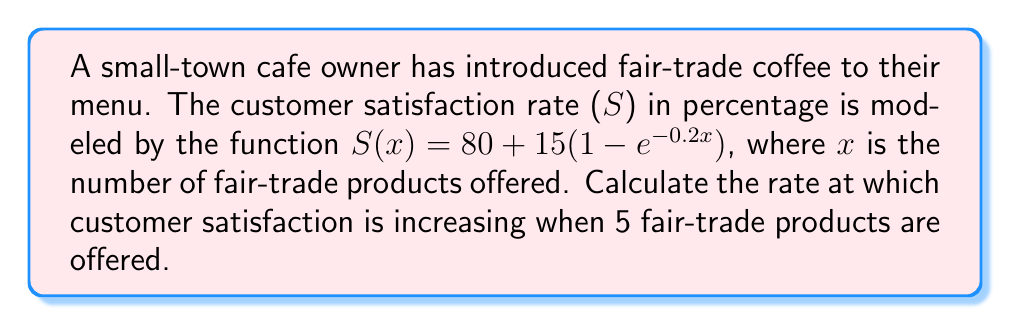Teach me how to tackle this problem. To find the rate at which customer satisfaction is increasing, we need to calculate the derivative of the function $S(x)$ and evaluate it at $x = 5$.

Step 1: Find the derivative of $S(x)$
$$\frac{d}{dx}S(x) = \frac{d}{dx}[80 + 15(1 - e^{-0.2x})]$$
$$S'(x) = 0 + 15 \cdot \frac{d}{dx}(1 - e^{-0.2x})$$
$$S'(x) = 15 \cdot (-1) \cdot (-0.2e^{-0.2x})$$
$$S'(x) = 3e^{-0.2x}$$

Step 2: Evaluate $S'(x)$ at $x = 5$
$$S'(5) = 3e^{-0.2(5)}$$
$$S'(5) = 3e^{-1}$$
$$S'(5) \approx 1.10$$

Therefore, when 5 fair-trade products are offered, the customer satisfaction rate is increasing at approximately 1.10 percentage points per additional fair-trade product.
Answer: $1.10$ percentage points per product 